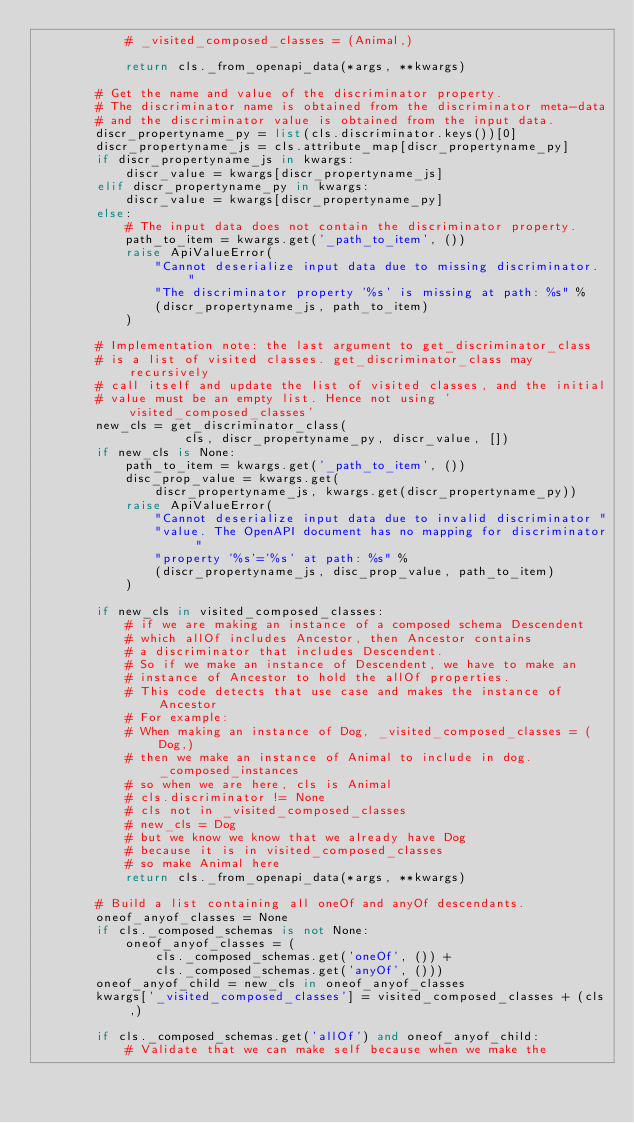<code> <loc_0><loc_0><loc_500><loc_500><_Python_>            # _visited_composed_classes = (Animal,)

            return cls._from_openapi_data(*args, **kwargs)

        # Get the name and value of the discriminator property.
        # The discriminator name is obtained from the discriminator meta-data
        # and the discriminator value is obtained from the input data.
        discr_propertyname_py = list(cls.discriminator.keys())[0]
        discr_propertyname_js = cls.attribute_map[discr_propertyname_py]
        if discr_propertyname_js in kwargs:
            discr_value = kwargs[discr_propertyname_js]
        elif discr_propertyname_py in kwargs:
            discr_value = kwargs[discr_propertyname_py]
        else:
            # The input data does not contain the discriminator property.
            path_to_item = kwargs.get('_path_to_item', ())
            raise ApiValueError(
                "Cannot deserialize input data due to missing discriminator. "
                "The discriminator property '%s' is missing at path: %s" %
                (discr_propertyname_js, path_to_item)
            )

        # Implementation note: the last argument to get_discriminator_class
        # is a list of visited classes. get_discriminator_class may recursively
        # call itself and update the list of visited classes, and the initial
        # value must be an empty list. Hence not using 'visited_composed_classes'
        new_cls = get_discriminator_class(
                    cls, discr_propertyname_py, discr_value, [])
        if new_cls is None:
            path_to_item = kwargs.get('_path_to_item', ())
            disc_prop_value = kwargs.get(
                discr_propertyname_js, kwargs.get(discr_propertyname_py))
            raise ApiValueError(
                "Cannot deserialize input data due to invalid discriminator "
                "value. The OpenAPI document has no mapping for discriminator "
                "property '%s'='%s' at path: %s" %
                (discr_propertyname_js, disc_prop_value, path_to_item)
            )

        if new_cls in visited_composed_classes:
            # if we are making an instance of a composed schema Descendent
            # which allOf includes Ancestor, then Ancestor contains
            # a discriminator that includes Descendent.
            # So if we make an instance of Descendent, we have to make an
            # instance of Ancestor to hold the allOf properties.
            # This code detects that use case and makes the instance of Ancestor
            # For example:
            # When making an instance of Dog, _visited_composed_classes = (Dog,)
            # then we make an instance of Animal to include in dog._composed_instances
            # so when we are here, cls is Animal
            # cls.discriminator != None
            # cls not in _visited_composed_classes
            # new_cls = Dog
            # but we know we know that we already have Dog
            # because it is in visited_composed_classes
            # so make Animal here
            return cls._from_openapi_data(*args, **kwargs)

        # Build a list containing all oneOf and anyOf descendants.
        oneof_anyof_classes = None
        if cls._composed_schemas is not None:
            oneof_anyof_classes = (
                cls._composed_schemas.get('oneOf', ()) +
                cls._composed_schemas.get('anyOf', ()))
        oneof_anyof_child = new_cls in oneof_anyof_classes
        kwargs['_visited_composed_classes'] = visited_composed_classes + (cls,)

        if cls._composed_schemas.get('allOf') and oneof_anyof_child:
            # Validate that we can make self because when we make the</code> 